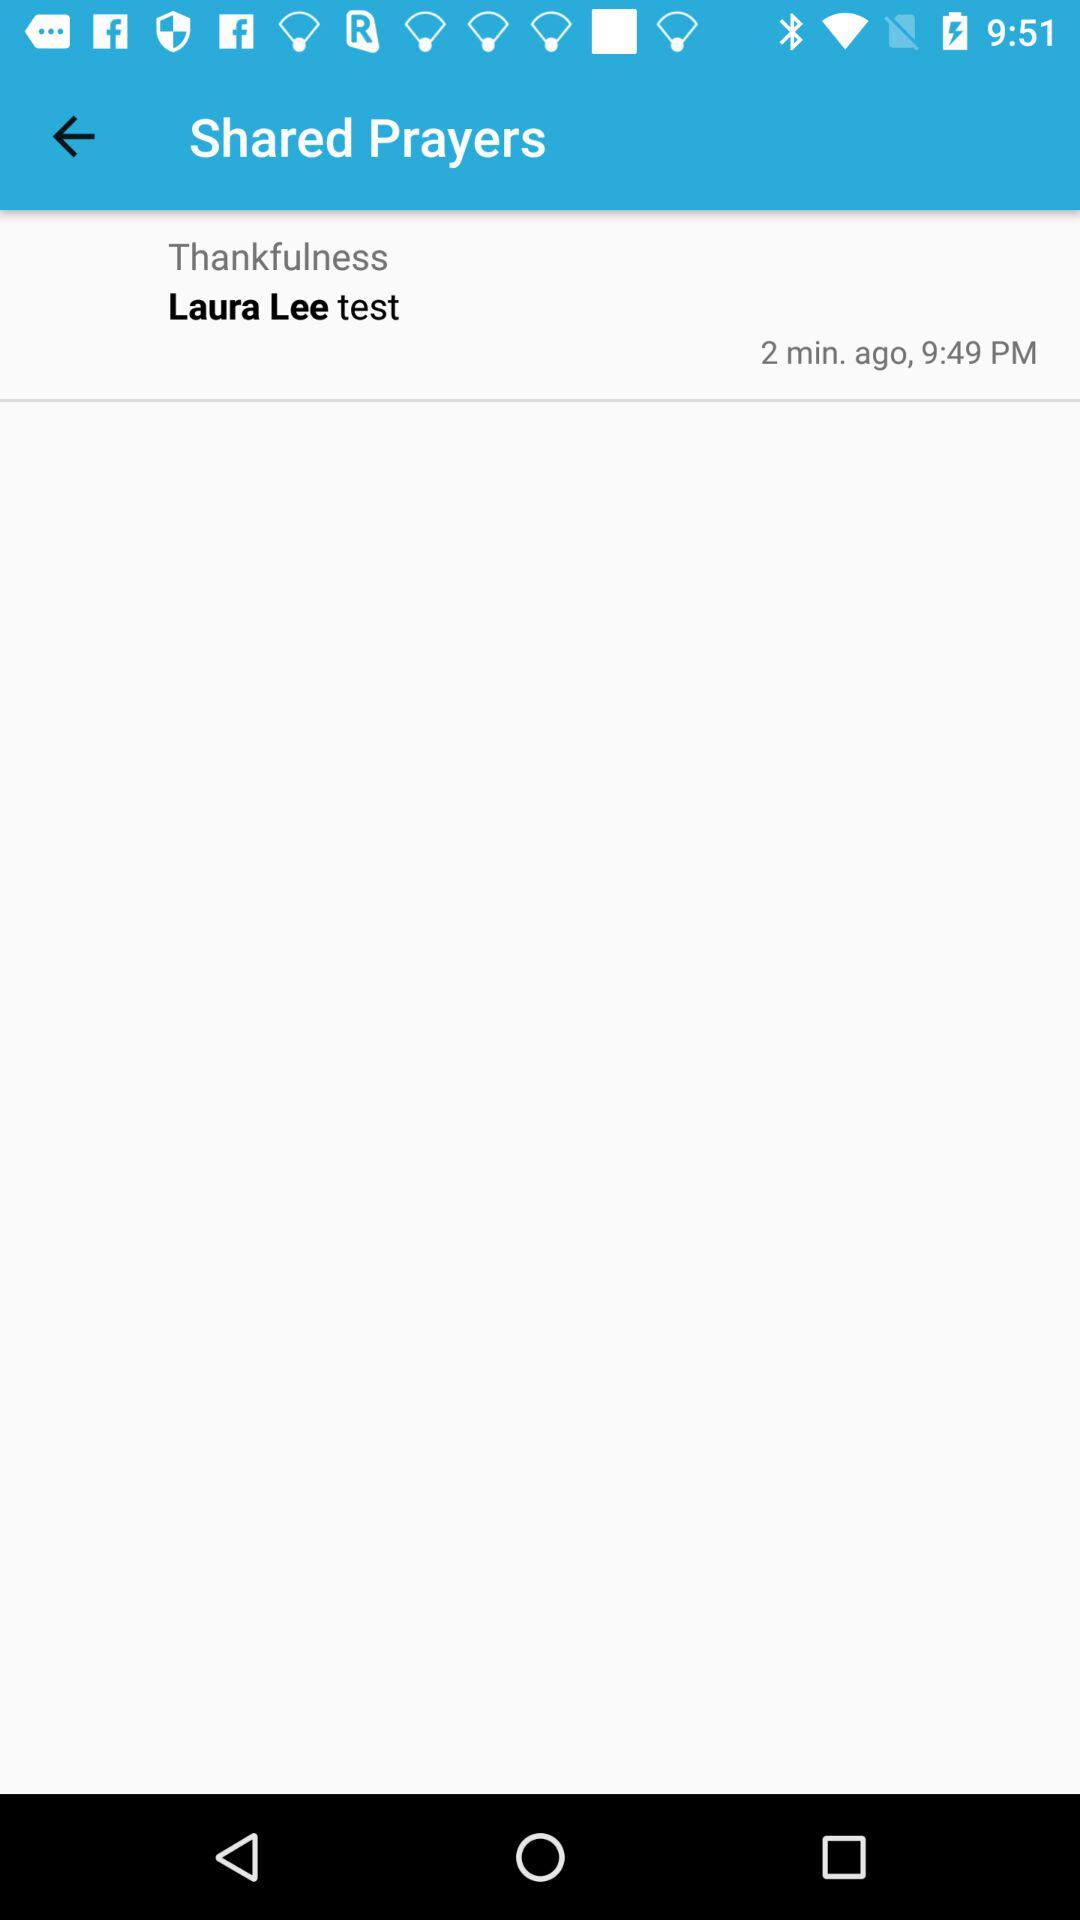What is the shown time? The shown time is 9:49 PM. 